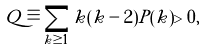<formula> <loc_0><loc_0><loc_500><loc_500>Q \equiv \sum _ { k \geq 1 } k ( k - 2 ) P ( k ) > 0 ,</formula> 